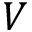Convert formula to latex. <formula><loc_0><loc_0><loc_500><loc_500>V</formula> 